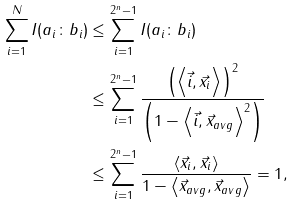Convert formula to latex. <formula><loc_0><loc_0><loc_500><loc_500>\sum _ { i = 1 } ^ { N } I ( a _ { i } \colon b _ { i } ) & \leq \sum _ { i = 1 } ^ { 2 ^ { n } - 1 } I ( a _ { i } \colon b _ { i } ) \\ & \leq \sum _ { i = 1 } ^ { 2 ^ { n } - 1 } \frac { \left ( \left \langle \vec { i } , \vec { x } _ { i } \right \rangle \right ) ^ { 2 } } { \left ( 1 - \left \langle \vec { i } , \vec { x } _ { a v g } \right \rangle ^ { 2 } \right ) } \\ & \leq \sum _ { i = 1 } ^ { 2 ^ { n } - 1 } \frac { \left \langle \vec { x } _ { i } , \vec { x } _ { i } \right \rangle } { 1 - \left \langle \vec { x } _ { a v g } , \vec { x } _ { a v g } \right \rangle } = 1 ,</formula> 